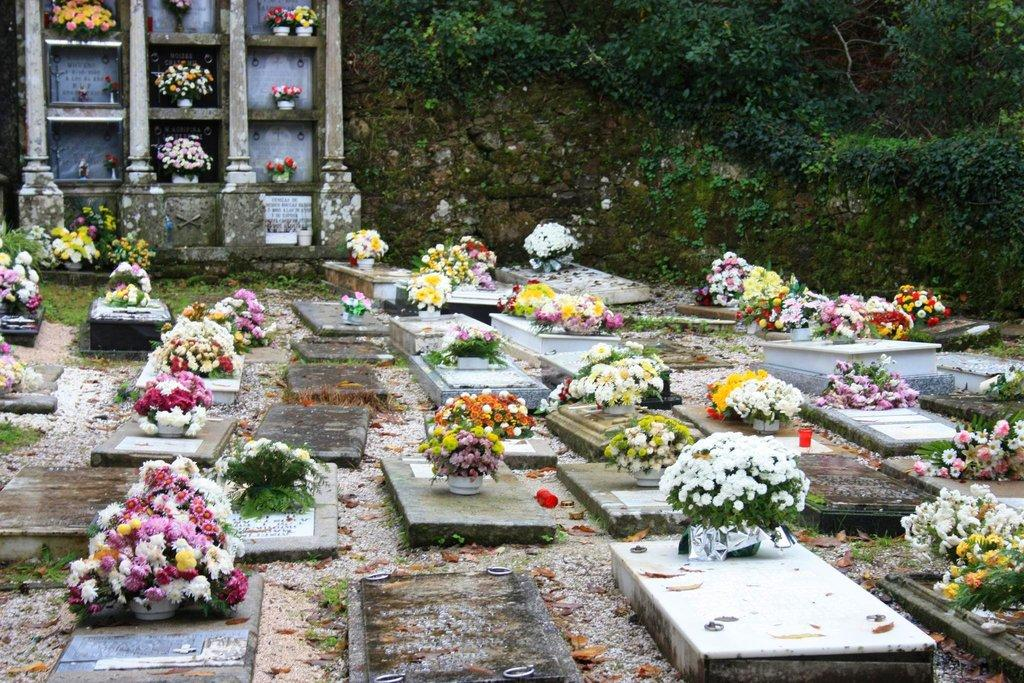What can be seen on the graves in the image? There are flower bouquets on the graves in the image. What is present on the ground in the image? There are leaves on the ground in the image. What type of vegetation is visible in the image? There are plants visible in the image. What type of bread can be seen in the image? There is no bread present in the image. What kind of patch is visible on the plants in the image? There is no patch visible on the plants in the image. 